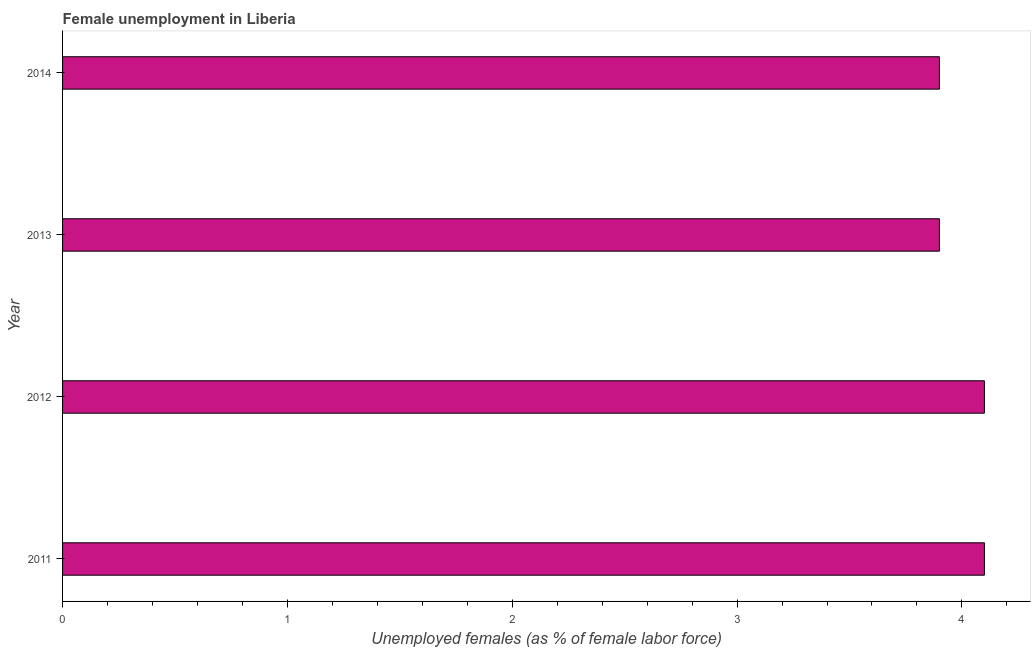What is the title of the graph?
Offer a very short reply. Female unemployment in Liberia. What is the label or title of the X-axis?
Your answer should be very brief. Unemployed females (as % of female labor force). What is the label or title of the Y-axis?
Your response must be concise. Year. What is the unemployed females population in 2014?
Your answer should be very brief. 3.9. Across all years, what is the maximum unemployed females population?
Your answer should be very brief. 4.1. Across all years, what is the minimum unemployed females population?
Your response must be concise. 3.9. What is the sum of the unemployed females population?
Your answer should be compact. 16. What is the median unemployed females population?
Give a very brief answer. 4. What is the ratio of the unemployed females population in 2012 to that in 2013?
Provide a short and direct response. 1.05. Is the sum of the unemployed females population in 2011 and 2012 greater than the maximum unemployed females population across all years?
Offer a terse response. Yes. What is the difference between the highest and the lowest unemployed females population?
Provide a succinct answer. 0.2. How many bars are there?
Offer a very short reply. 4. Are the values on the major ticks of X-axis written in scientific E-notation?
Your answer should be compact. No. What is the Unemployed females (as % of female labor force) in 2011?
Ensure brevity in your answer.  4.1. What is the Unemployed females (as % of female labor force) in 2012?
Offer a terse response. 4.1. What is the Unemployed females (as % of female labor force) of 2013?
Make the answer very short. 3.9. What is the Unemployed females (as % of female labor force) of 2014?
Your answer should be compact. 3.9. What is the difference between the Unemployed females (as % of female labor force) in 2011 and 2012?
Provide a short and direct response. 0. What is the difference between the Unemployed females (as % of female labor force) in 2011 and 2013?
Provide a succinct answer. 0.2. What is the difference between the Unemployed females (as % of female labor force) in 2011 and 2014?
Make the answer very short. 0.2. What is the difference between the Unemployed females (as % of female labor force) in 2012 and 2013?
Make the answer very short. 0.2. What is the ratio of the Unemployed females (as % of female labor force) in 2011 to that in 2012?
Make the answer very short. 1. What is the ratio of the Unemployed females (as % of female labor force) in 2011 to that in 2013?
Ensure brevity in your answer.  1.05. What is the ratio of the Unemployed females (as % of female labor force) in 2011 to that in 2014?
Keep it short and to the point. 1.05. What is the ratio of the Unemployed females (as % of female labor force) in 2012 to that in 2013?
Offer a very short reply. 1.05. What is the ratio of the Unemployed females (as % of female labor force) in 2012 to that in 2014?
Keep it short and to the point. 1.05. What is the ratio of the Unemployed females (as % of female labor force) in 2013 to that in 2014?
Offer a terse response. 1. 